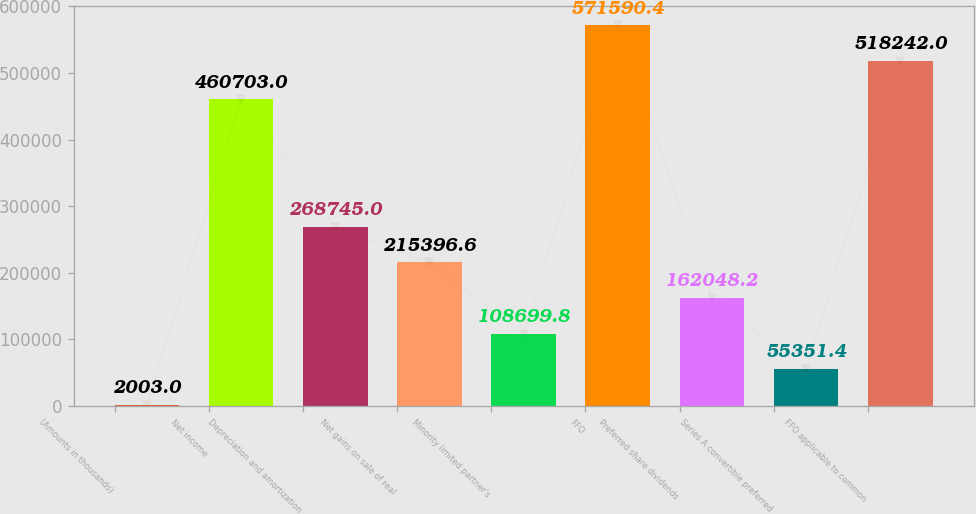Convert chart to OTSL. <chart><loc_0><loc_0><loc_500><loc_500><bar_chart><fcel>(Amounts in thousands)<fcel>Net income<fcel>Depreciation and amortization<fcel>Net gains on sale of real<fcel>Minority limited partner's<fcel>FFO<fcel>Preferred share dividends<fcel>Series A convertible preferred<fcel>FFO applicable to common<nl><fcel>2003<fcel>460703<fcel>268745<fcel>215397<fcel>108700<fcel>571590<fcel>162048<fcel>55351.4<fcel>518242<nl></chart> 